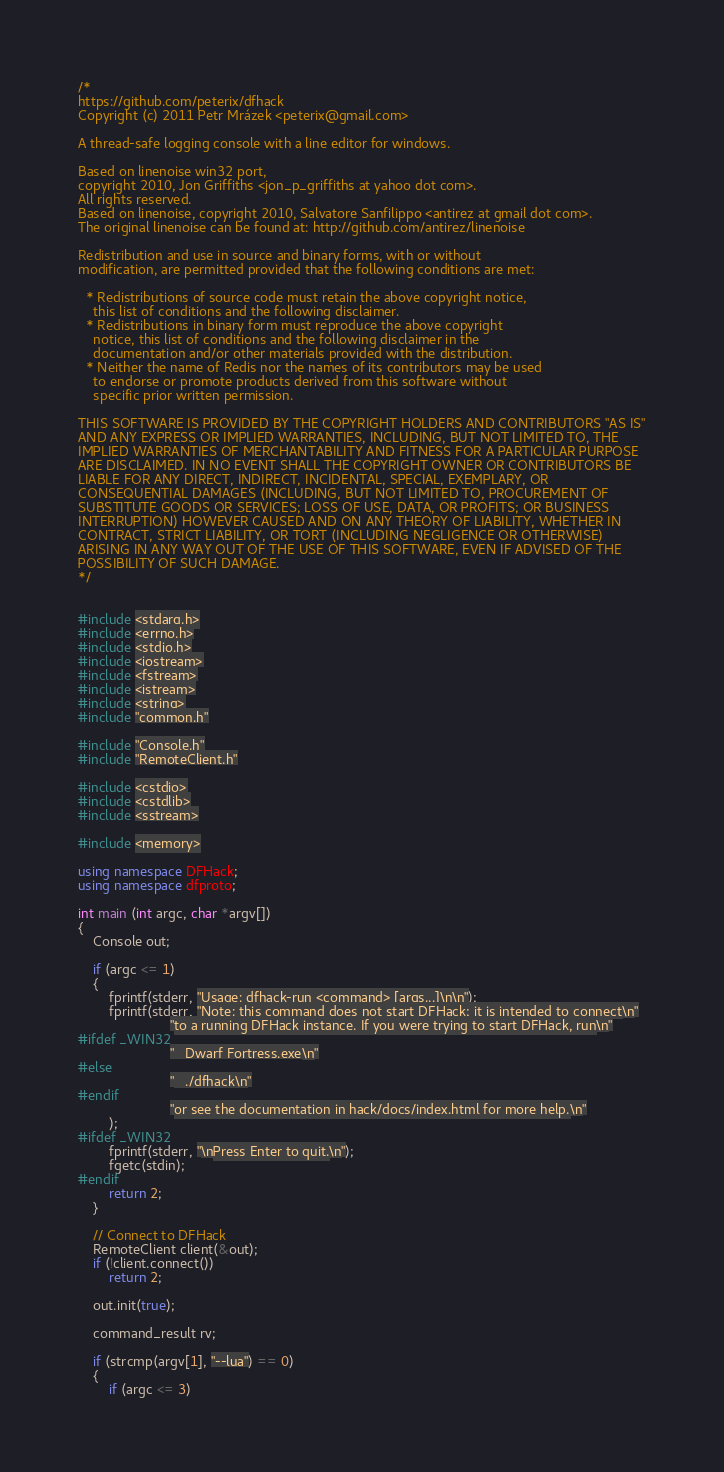Convert code to text. <code><loc_0><loc_0><loc_500><loc_500><_C++_>/*
https://github.com/peterix/dfhack
Copyright (c) 2011 Petr Mrázek <peterix@gmail.com>

A thread-safe logging console with a line editor for windows.

Based on linenoise win32 port,
copyright 2010, Jon Griffiths <jon_p_griffiths at yahoo dot com>.
All rights reserved.
Based on linenoise, copyright 2010, Salvatore Sanfilippo <antirez at gmail dot com>.
The original linenoise can be found at: http://github.com/antirez/linenoise

Redistribution and use in source and binary forms, with or without
modification, are permitted provided that the following conditions are met:

  * Redistributions of source code must retain the above copyright notice,
    this list of conditions and the following disclaimer.
  * Redistributions in binary form must reproduce the above copyright
    notice, this list of conditions and the following disclaimer in the
    documentation and/or other materials provided with the distribution.
  * Neither the name of Redis nor the names of its contributors may be used
    to endorse or promote products derived from this software without
    specific prior written permission.

THIS SOFTWARE IS PROVIDED BY THE COPYRIGHT HOLDERS AND CONTRIBUTORS "AS IS"
AND ANY EXPRESS OR IMPLIED WARRANTIES, INCLUDING, BUT NOT LIMITED TO, THE
IMPLIED WARRANTIES OF MERCHANTABILITY AND FITNESS FOR A PARTICULAR PURPOSE
ARE DISCLAIMED. IN NO EVENT SHALL THE COPYRIGHT OWNER OR CONTRIBUTORS BE
LIABLE FOR ANY DIRECT, INDIRECT, INCIDENTAL, SPECIAL, EXEMPLARY, OR
CONSEQUENTIAL DAMAGES (INCLUDING, BUT NOT LIMITED TO, PROCUREMENT OF
SUBSTITUTE GOODS OR SERVICES; LOSS OF USE, DATA, OR PROFITS; OR BUSINESS
INTERRUPTION) HOWEVER CAUSED AND ON ANY THEORY OF LIABILITY, WHETHER IN
CONTRACT, STRICT LIABILITY, OR TORT (INCLUDING NEGLIGENCE OR OTHERWISE)
ARISING IN ANY WAY OUT OF THE USE OF THIS SOFTWARE, EVEN IF ADVISED OF THE
POSSIBILITY OF SUCH DAMAGE.
*/


#include <stdarg.h>
#include <errno.h>
#include <stdio.h>
#include <iostream>
#include <fstream>
#include <istream>
#include <string>
#include "common.h"

#include "Console.h"
#include "RemoteClient.h"

#include <cstdio>
#include <cstdlib>
#include <sstream>

#include <memory>

using namespace DFHack;
using namespace dfproto;

int main (int argc, char *argv[])
{
    Console out;

    if (argc <= 1)
    {
        fprintf(stderr, "Usage: dfhack-run <command> [args...]\n\n");
        fprintf(stderr, "Note: this command does not start DFHack; it is intended to connect\n"
                        "to a running DFHack instance. If you were trying to start DFHack, run\n"
#ifdef _WIN32
                        "   Dwarf Fortress.exe\n"
#else
                        "   ./dfhack\n"
#endif
                        "or see the documentation in hack/docs/index.html for more help.\n"
        );
#ifdef _WIN32
        fprintf(stderr, "\nPress Enter to quit.\n");
        fgetc(stdin);
#endif
        return 2;
    }

    // Connect to DFHack
    RemoteClient client(&out);
    if (!client.connect())
        return 2;

    out.init(true);

    command_result rv;

    if (strcmp(argv[1], "--lua") == 0)
    {
        if (argc <= 3)</code> 